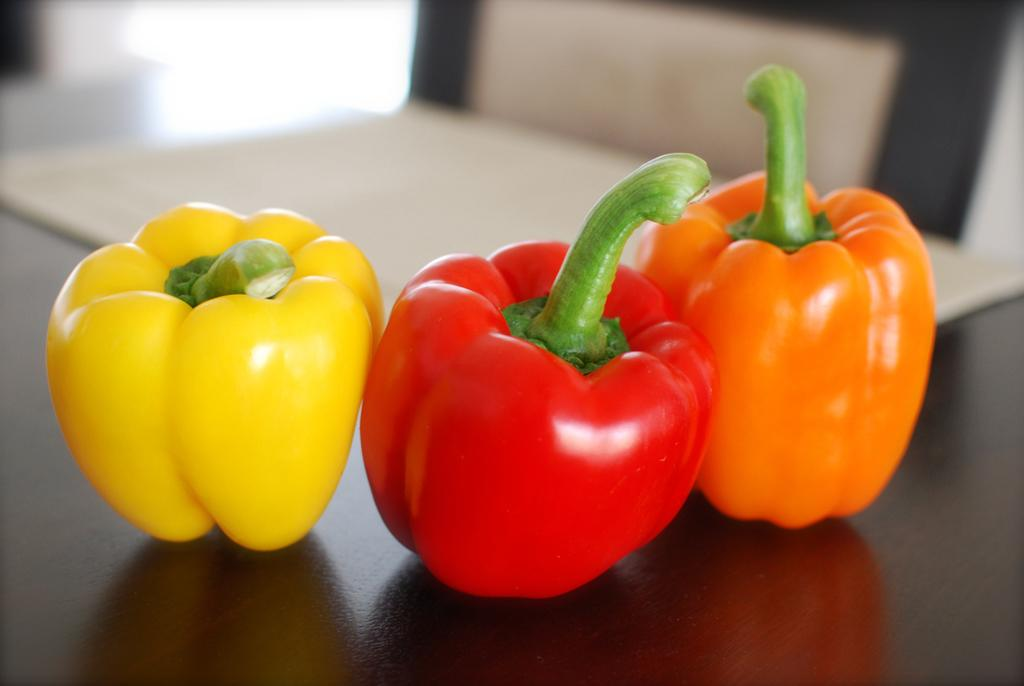What is the main object in the image? There is a table in the image. What is placed on the table? There are different types of capsicums on the table. How many ducks are sitting on the table in the image? There are no ducks present in the image; it only features a table with capsicums on it. What type of tin can be seen in the image? There is no tin present in the image. 